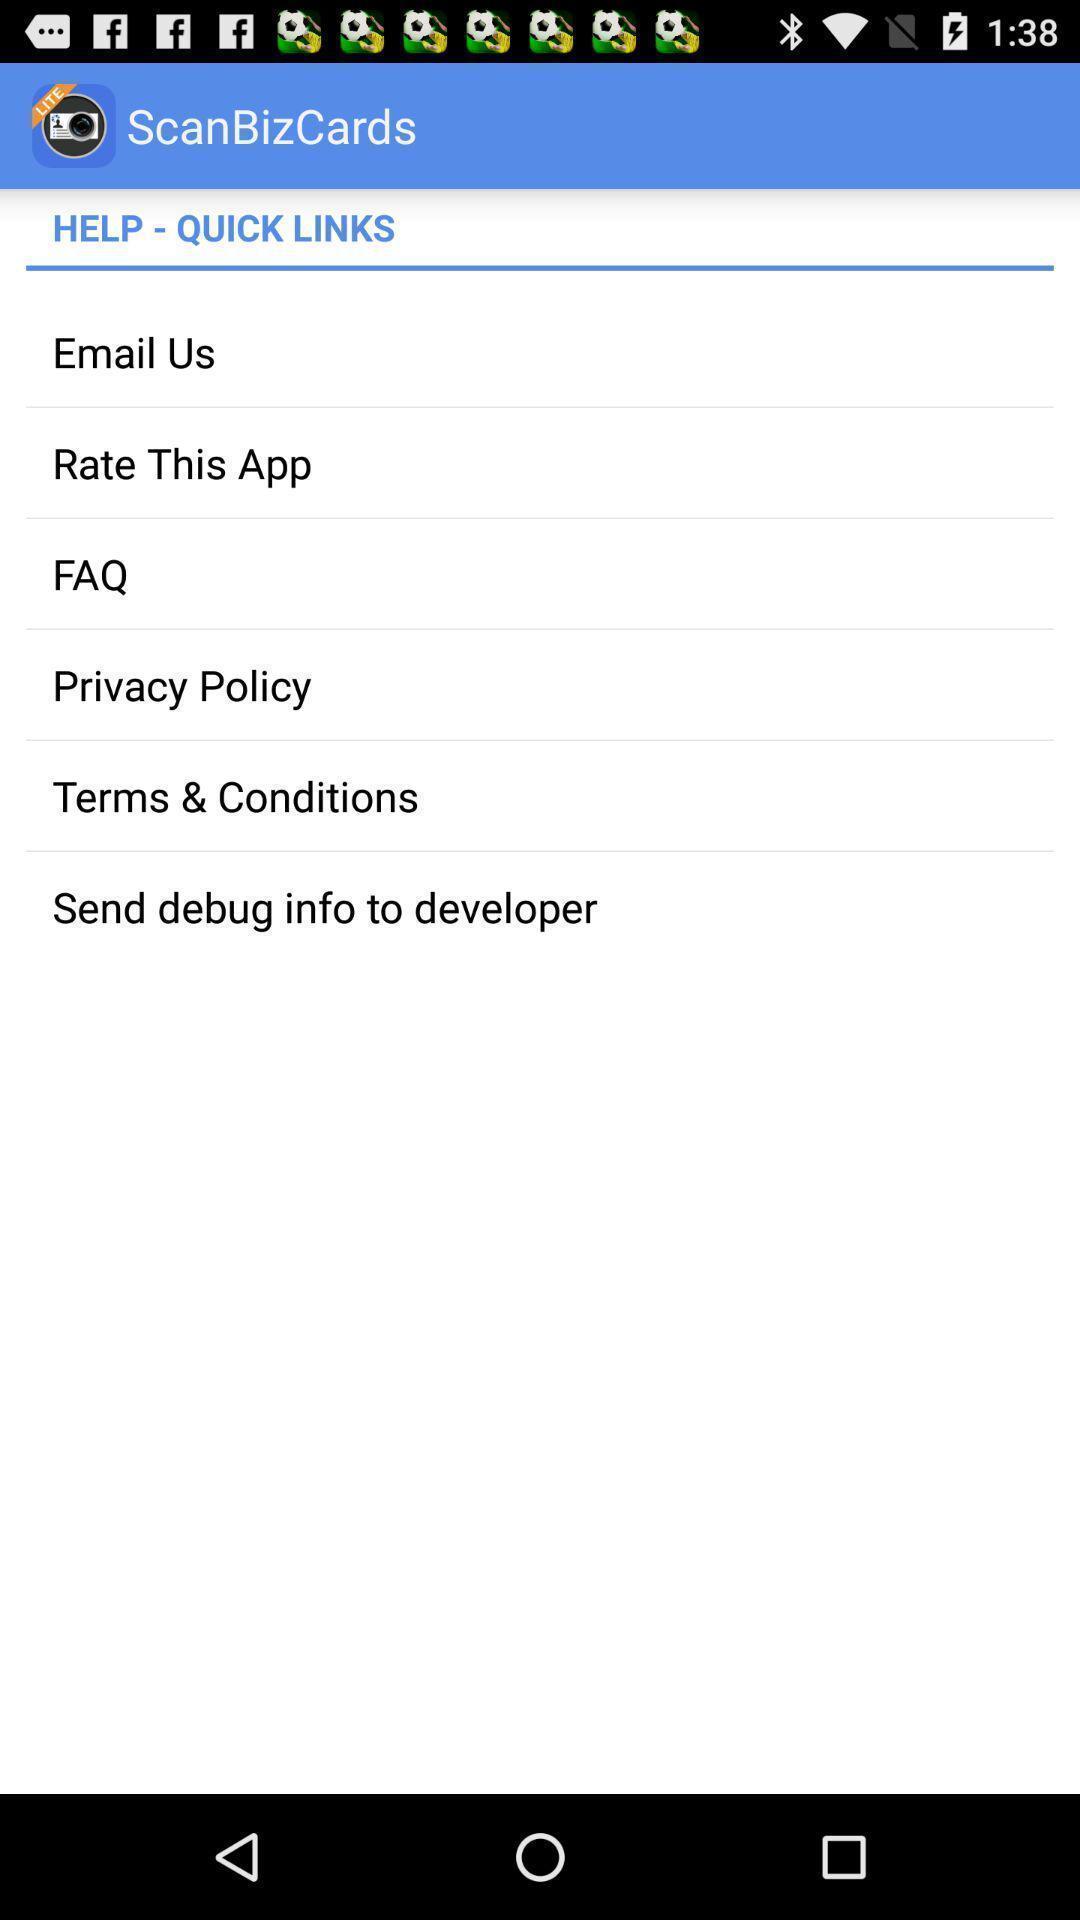Tell me what you see in this picture. Screen displaying the help page. 